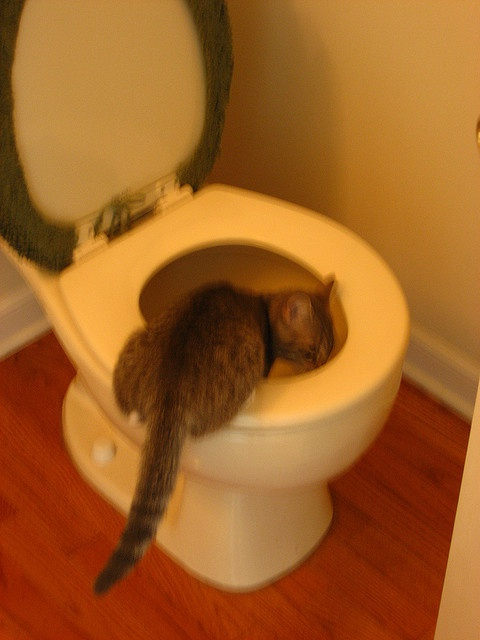Describe the objects in this image and their specific colors. I can see toilet in black, orange, olive, and tan tones and cat in black, maroon, and brown tones in this image. 